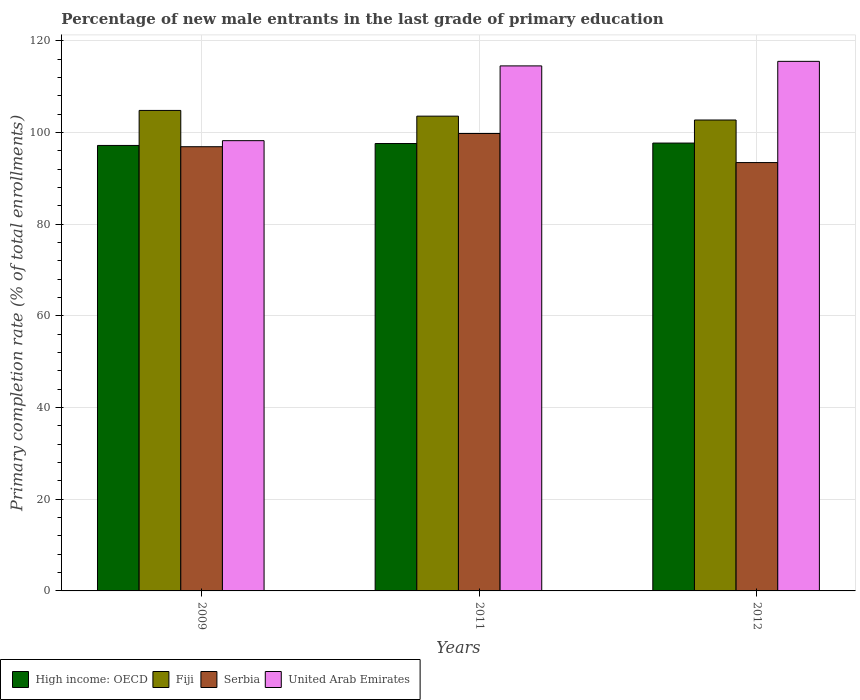How many bars are there on the 2nd tick from the left?
Offer a terse response. 4. How many bars are there on the 3rd tick from the right?
Provide a short and direct response. 4. In how many cases, is the number of bars for a given year not equal to the number of legend labels?
Ensure brevity in your answer.  0. What is the percentage of new male entrants in High income: OECD in 2012?
Give a very brief answer. 97.73. Across all years, what is the maximum percentage of new male entrants in Fiji?
Keep it short and to the point. 104.85. Across all years, what is the minimum percentage of new male entrants in Fiji?
Your answer should be compact. 102.76. In which year was the percentage of new male entrants in Fiji maximum?
Provide a short and direct response. 2009. In which year was the percentage of new male entrants in Serbia minimum?
Your answer should be very brief. 2012. What is the total percentage of new male entrants in Fiji in the graph?
Give a very brief answer. 311.21. What is the difference between the percentage of new male entrants in Fiji in 2009 and that in 2012?
Your response must be concise. 2.09. What is the difference between the percentage of new male entrants in High income: OECD in 2011 and the percentage of new male entrants in Serbia in 2009?
Make the answer very short. 0.7. What is the average percentage of new male entrants in Fiji per year?
Offer a terse response. 103.74. In the year 2011, what is the difference between the percentage of new male entrants in High income: OECD and percentage of new male entrants in United Arab Emirates?
Your response must be concise. -16.94. In how many years, is the percentage of new male entrants in Serbia greater than 92 %?
Provide a short and direct response. 3. What is the ratio of the percentage of new male entrants in Serbia in 2009 to that in 2011?
Keep it short and to the point. 0.97. Is the difference between the percentage of new male entrants in High income: OECD in 2009 and 2012 greater than the difference between the percentage of new male entrants in United Arab Emirates in 2009 and 2012?
Ensure brevity in your answer.  Yes. What is the difference between the highest and the second highest percentage of new male entrants in High income: OECD?
Offer a very short reply. 0.1. What is the difference between the highest and the lowest percentage of new male entrants in Serbia?
Keep it short and to the point. 6.34. Is it the case that in every year, the sum of the percentage of new male entrants in Fiji and percentage of new male entrants in Serbia is greater than the sum of percentage of new male entrants in High income: OECD and percentage of new male entrants in United Arab Emirates?
Keep it short and to the point. No. What does the 1st bar from the left in 2009 represents?
Give a very brief answer. High income: OECD. What does the 2nd bar from the right in 2009 represents?
Ensure brevity in your answer.  Serbia. How many bars are there?
Your response must be concise. 12. Are all the bars in the graph horizontal?
Your answer should be compact. No. Are the values on the major ticks of Y-axis written in scientific E-notation?
Give a very brief answer. No. Does the graph contain grids?
Give a very brief answer. Yes. What is the title of the graph?
Your answer should be compact. Percentage of new male entrants in the last grade of primary education. Does "Egypt, Arab Rep." appear as one of the legend labels in the graph?
Give a very brief answer. No. What is the label or title of the X-axis?
Provide a short and direct response. Years. What is the label or title of the Y-axis?
Provide a succinct answer. Primary completion rate (% of total enrollments). What is the Primary completion rate (% of total enrollments) of High income: OECD in 2009?
Keep it short and to the point. 97.21. What is the Primary completion rate (% of total enrollments) in Fiji in 2009?
Ensure brevity in your answer.  104.85. What is the Primary completion rate (% of total enrollments) of Serbia in 2009?
Keep it short and to the point. 96.93. What is the Primary completion rate (% of total enrollments) of United Arab Emirates in 2009?
Your response must be concise. 98.25. What is the Primary completion rate (% of total enrollments) of High income: OECD in 2011?
Provide a succinct answer. 97.63. What is the Primary completion rate (% of total enrollments) in Fiji in 2011?
Your answer should be compact. 103.6. What is the Primary completion rate (% of total enrollments) of Serbia in 2011?
Your response must be concise. 99.81. What is the Primary completion rate (% of total enrollments) in United Arab Emirates in 2011?
Offer a very short reply. 114.56. What is the Primary completion rate (% of total enrollments) in High income: OECD in 2012?
Provide a short and direct response. 97.73. What is the Primary completion rate (% of total enrollments) in Fiji in 2012?
Offer a terse response. 102.76. What is the Primary completion rate (% of total enrollments) in Serbia in 2012?
Give a very brief answer. 93.47. What is the Primary completion rate (% of total enrollments) in United Arab Emirates in 2012?
Ensure brevity in your answer.  115.56. Across all years, what is the maximum Primary completion rate (% of total enrollments) in High income: OECD?
Your answer should be compact. 97.73. Across all years, what is the maximum Primary completion rate (% of total enrollments) of Fiji?
Offer a terse response. 104.85. Across all years, what is the maximum Primary completion rate (% of total enrollments) in Serbia?
Keep it short and to the point. 99.81. Across all years, what is the maximum Primary completion rate (% of total enrollments) of United Arab Emirates?
Offer a terse response. 115.56. Across all years, what is the minimum Primary completion rate (% of total enrollments) in High income: OECD?
Provide a succinct answer. 97.21. Across all years, what is the minimum Primary completion rate (% of total enrollments) in Fiji?
Provide a short and direct response. 102.76. Across all years, what is the minimum Primary completion rate (% of total enrollments) in Serbia?
Offer a terse response. 93.47. Across all years, what is the minimum Primary completion rate (% of total enrollments) of United Arab Emirates?
Give a very brief answer. 98.25. What is the total Primary completion rate (% of total enrollments) of High income: OECD in the graph?
Make the answer very short. 292.56. What is the total Primary completion rate (% of total enrollments) of Fiji in the graph?
Ensure brevity in your answer.  311.21. What is the total Primary completion rate (% of total enrollments) of Serbia in the graph?
Keep it short and to the point. 290.21. What is the total Primary completion rate (% of total enrollments) in United Arab Emirates in the graph?
Provide a succinct answer. 328.37. What is the difference between the Primary completion rate (% of total enrollments) of High income: OECD in 2009 and that in 2011?
Your answer should be very brief. -0.42. What is the difference between the Primary completion rate (% of total enrollments) in Fiji in 2009 and that in 2011?
Provide a short and direct response. 1.25. What is the difference between the Primary completion rate (% of total enrollments) in Serbia in 2009 and that in 2011?
Give a very brief answer. -2.88. What is the difference between the Primary completion rate (% of total enrollments) of United Arab Emirates in 2009 and that in 2011?
Provide a short and direct response. -16.31. What is the difference between the Primary completion rate (% of total enrollments) in High income: OECD in 2009 and that in 2012?
Your response must be concise. -0.52. What is the difference between the Primary completion rate (% of total enrollments) in Fiji in 2009 and that in 2012?
Provide a succinct answer. 2.09. What is the difference between the Primary completion rate (% of total enrollments) in Serbia in 2009 and that in 2012?
Give a very brief answer. 3.46. What is the difference between the Primary completion rate (% of total enrollments) in United Arab Emirates in 2009 and that in 2012?
Keep it short and to the point. -17.31. What is the difference between the Primary completion rate (% of total enrollments) of High income: OECD in 2011 and that in 2012?
Ensure brevity in your answer.  -0.1. What is the difference between the Primary completion rate (% of total enrollments) in Fiji in 2011 and that in 2012?
Keep it short and to the point. 0.84. What is the difference between the Primary completion rate (% of total enrollments) in Serbia in 2011 and that in 2012?
Offer a very short reply. 6.34. What is the difference between the Primary completion rate (% of total enrollments) in United Arab Emirates in 2011 and that in 2012?
Your response must be concise. -0.99. What is the difference between the Primary completion rate (% of total enrollments) of High income: OECD in 2009 and the Primary completion rate (% of total enrollments) of Fiji in 2011?
Your answer should be compact. -6.39. What is the difference between the Primary completion rate (% of total enrollments) in High income: OECD in 2009 and the Primary completion rate (% of total enrollments) in Serbia in 2011?
Ensure brevity in your answer.  -2.6. What is the difference between the Primary completion rate (% of total enrollments) of High income: OECD in 2009 and the Primary completion rate (% of total enrollments) of United Arab Emirates in 2011?
Give a very brief answer. -17.36. What is the difference between the Primary completion rate (% of total enrollments) of Fiji in 2009 and the Primary completion rate (% of total enrollments) of Serbia in 2011?
Offer a very short reply. 5.04. What is the difference between the Primary completion rate (% of total enrollments) in Fiji in 2009 and the Primary completion rate (% of total enrollments) in United Arab Emirates in 2011?
Keep it short and to the point. -9.71. What is the difference between the Primary completion rate (% of total enrollments) in Serbia in 2009 and the Primary completion rate (% of total enrollments) in United Arab Emirates in 2011?
Your answer should be very brief. -17.63. What is the difference between the Primary completion rate (% of total enrollments) in High income: OECD in 2009 and the Primary completion rate (% of total enrollments) in Fiji in 2012?
Give a very brief answer. -5.55. What is the difference between the Primary completion rate (% of total enrollments) in High income: OECD in 2009 and the Primary completion rate (% of total enrollments) in Serbia in 2012?
Ensure brevity in your answer.  3.74. What is the difference between the Primary completion rate (% of total enrollments) of High income: OECD in 2009 and the Primary completion rate (% of total enrollments) of United Arab Emirates in 2012?
Make the answer very short. -18.35. What is the difference between the Primary completion rate (% of total enrollments) of Fiji in 2009 and the Primary completion rate (% of total enrollments) of Serbia in 2012?
Provide a succinct answer. 11.38. What is the difference between the Primary completion rate (% of total enrollments) in Fiji in 2009 and the Primary completion rate (% of total enrollments) in United Arab Emirates in 2012?
Make the answer very short. -10.71. What is the difference between the Primary completion rate (% of total enrollments) in Serbia in 2009 and the Primary completion rate (% of total enrollments) in United Arab Emirates in 2012?
Keep it short and to the point. -18.63. What is the difference between the Primary completion rate (% of total enrollments) in High income: OECD in 2011 and the Primary completion rate (% of total enrollments) in Fiji in 2012?
Make the answer very short. -5.13. What is the difference between the Primary completion rate (% of total enrollments) in High income: OECD in 2011 and the Primary completion rate (% of total enrollments) in Serbia in 2012?
Offer a very short reply. 4.15. What is the difference between the Primary completion rate (% of total enrollments) of High income: OECD in 2011 and the Primary completion rate (% of total enrollments) of United Arab Emirates in 2012?
Provide a short and direct response. -17.93. What is the difference between the Primary completion rate (% of total enrollments) in Fiji in 2011 and the Primary completion rate (% of total enrollments) in Serbia in 2012?
Give a very brief answer. 10.13. What is the difference between the Primary completion rate (% of total enrollments) in Fiji in 2011 and the Primary completion rate (% of total enrollments) in United Arab Emirates in 2012?
Offer a terse response. -11.96. What is the difference between the Primary completion rate (% of total enrollments) in Serbia in 2011 and the Primary completion rate (% of total enrollments) in United Arab Emirates in 2012?
Your response must be concise. -15.74. What is the average Primary completion rate (% of total enrollments) of High income: OECD per year?
Provide a short and direct response. 97.52. What is the average Primary completion rate (% of total enrollments) in Fiji per year?
Your response must be concise. 103.74. What is the average Primary completion rate (% of total enrollments) in Serbia per year?
Your response must be concise. 96.74. What is the average Primary completion rate (% of total enrollments) of United Arab Emirates per year?
Ensure brevity in your answer.  109.46. In the year 2009, what is the difference between the Primary completion rate (% of total enrollments) of High income: OECD and Primary completion rate (% of total enrollments) of Fiji?
Your answer should be very brief. -7.64. In the year 2009, what is the difference between the Primary completion rate (% of total enrollments) in High income: OECD and Primary completion rate (% of total enrollments) in Serbia?
Your answer should be compact. 0.28. In the year 2009, what is the difference between the Primary completion rate (% of total enrollments) of High income: OECD and Primary completion rate (% of total enrollments) of United Arab Emirates?
Offer a very short reply. -1.04. In the year 2009, what is the difference between the Primary completion rate (% of total enrollments) in Fiji and Primary completion rate (% of total enrollments) in Serbia?
Your answer should be very brief. 7.92. In the year 2009, what is the difference between the Primary completion rate (% of total enrollments) in Fiji and Primary completion rate (% of total enrollments) in United Arab Emirates?
Provide a succinct answer. 6.6. In the year 2009, what is the difference between the Primary completion rate (% of total enrollments) of Serbia and Primary completion rate (% of total enrollments) of United Arab Emirates?
Provide a short and direct response. -1.32. In the year 2011, what is the difference between the Primary completion rate (% of total enrollments) in High income: OECD and Primary completion rate (% of total enrollments) in Fiji?
Your response must be concise. -5.97. In the year 2011, what is the difference between the Primary completion rate (% of total enrollments) in High income: OECD and Primary completion rate (% of total enrollments) in Serbia?
Keep it short and to the point. -2.19. In the year 2011, what is the difference between the Primary completion rate (% of total enrollments) of High income: OECD and Primary completion rate (% of total enrollments) of United Arab Emirates?
Offer a terse response. -16.94. In the year 2011, what is the difference between the Primary completion rate (% of total enrollments) in Fiji and Primary completion rate (% of total enrollments) in Serbia?
Offer a terse response. 3.79. In the year 2011, what is the difference between the Primary completion rate (% of total enrollments) of Fiji and Primary completion rate (% of total enrollments) of United Arab Emirates?
Your answer should be very brief. -10.97. In the year 2011, what is the difference between the Primary completion rate (% of total enrollments) of Serbia and Primary completion rate (% of total enrollments) of United Arab Emirates?
Keep it short and to the point. -14.75. In the year 2012, what is the difference between the Primary completion rate (% of total enrollments) of High income: OECD and Primary completion rate (% of total enrollments) of Fiji?
Your answer should be very brief. -5.03. In the year 2012, what is the difference between the Primary completion rate (% of total enrollments) in High income: OECD and Primary completion rate (% of total enrollments) in Serbia?
Offer a very short reply. 4.26. In the year 2012, what is the difference between the Primary completion rate (% of total enrollments) of High income: OECD and Primary completion rate (% of total enrollments) of United Arab Emirates?
Provide a succinct answer. -17.83. In the year 2012, what is the difference between the Primary completion rate (% of total enrollments) in Fiji and Primary completion rate (% of total enrollments) in Serbia?
Your answer should be compact. 9.29. In the year 2012, what is the difference between the Primary completion rate (% of total enrollments) of Fiji and Primary completion rate (% of total enrollments) of United Arab Emirates?
Give a very brief answer. -12.8. In the year 2012, what is the difference between the Primary completion rate (% of total enrollments) of Serbia and Primary completion rate (% of total enrollments) of United Arab Emirates?
Make the answer very short. -22.09. What is the ratio of the Primary completion rate (% of total enrollments) in High income: OECD in 2009 to that in 2011?
Your answer should be compact. 1. What is the ratio of the Primary completion rate (% of total enrollments) in Fiji in 2009 to that in 2011?
Your answer should be compact. 1.01. What is the ratio of the Primary completion rate (% of total enrollments) in Serbia in 2009 to that in 2011?
Offer a very short reply. 0.97. What is the ratio of the Primary completion rate (% of total enrollments) in United Arab Emirates in 2009 to that in 2011?
Ensure brevity in your answer.  0.86. What is the ratio of the Primary completion rate (% of total enrollments) in Fiji in 2009 to that in 2012?
Provide a short and direct response. 1.02. What is the ratio of the Primary completion rate (% of total enrollments) of Serbia in 2009 to that in 2012?
Your answer should be very brief. 1.04. What is the ratio of the Primary completion rate (% of total enrollments) of United Arab Emirates in 2009 to that in 2012?
Your response must be concise. 0.85. What is the ratio of the Primary completion rate (% of total enrollments) in High income: OECD in 2011 to that in 2012?
Give a very brief answer. 1. What is the ratio of the Primary completion rate (% of total enrollments) in Fiji in 2011 to that in 2012?
Offer a very short reply. 1.01. What is the ratio of the Primary completion rate (% of total enrollments) of Serbia in 2011 to that in 2012?
Ensure brevity in your answer.  1.07. What is the ratio of the Primary completion rate (% of total enrollments) of United Arab Emirates in 2011 to that in 2012?
Keep it short and to the point. 0.99. What is the difference between the highest and the second highest Primary completion rate (% of total enrollments) of High income: OECD?
Keep it short and to the point. 0.1. What is the difference between the highest and the second highest Primary completion rate (% of total enrollments) in Fiji?
Your answer should be compact. 1.25. What is the difference between the highest and the second highest Primary completion rate (% of total enrollments) in Serbia?
Your answer should be very brief. 2.88. What is the difference between the highest and the lowest Primary completion rate (% of total enrollments) of High income: OECD?
Offer a very short reply. 0.52. What is the difference between the highest and the lowest Primary completion rate (% of total enrollments) of Fiji?
Keep it short and to the point. 2.09. What is the difference between the highest and the lowest Primary completion rate (% of total enrollments) in Serbia?
Make the answer very short. 6.34. What is the difference between the highest and the lowest Primary completion rate (% of total enrollments) in United Arab Emirates?
Your response must be concise. 17.31. 